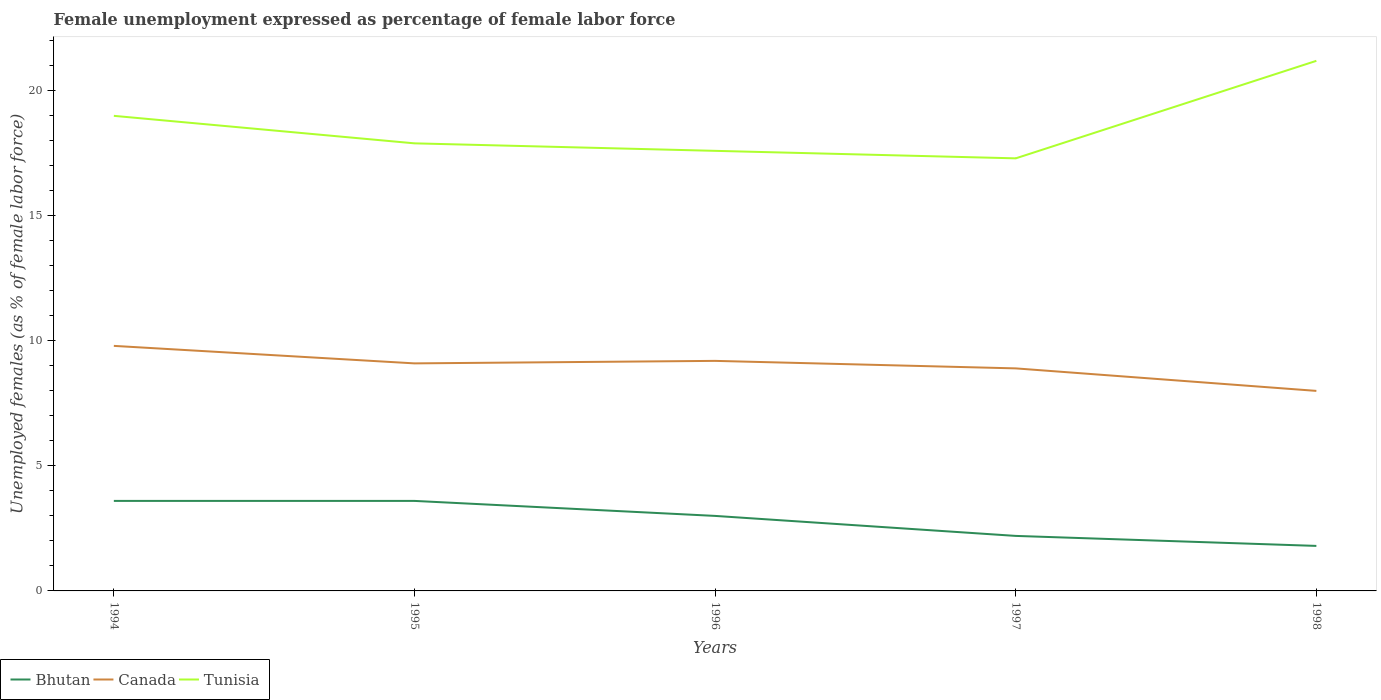How many different coloured lines are there?
Give a very brief answer. 3. Does the line corresponding to Tunisia intersect with the line corresponding to Bhutan?
Keep it short and to the point. No. Across all years, what is the maximum unemployment in females in in Bhutan?
Your response must be concise. 1.8. In which year was the unemployment in females in in Bhutan maximum?
Keep it short and to the point. 1998. What is the total unemployment in females in in Canada in the graph?
Give a very brief answer. 1.2. What is the difference between the highest and the second highest unemployment in females in in Bhutan?
Your response must be concise. 1.8. Are the values on the major ticks of Y-axis written in scientific E-notation?
Give a very brief answer. No. Does the graph contain grids?
Your answer should be very brief. No. How are the legend labels stacked?
Give a very brief answer. Horizontal. What is the title of the graph?
Give a very brief answer. Female unemployment expressed as percentage of female labor force. What is the label or title of the X-axis?
Your answer should be compact. Years. What is the label or title of the Y-axis?
Give a very brief answer. Unemployed females (as % of female labor force). What is the Unemployed females (as % of female labor force) of Bhutan in 1994?
Your answer should be compact. 3.6. What is the Unemployed females (as % of female labor force) of Canada in 1994?
Keep it short and to the point. 9.8. What is the Unemployed females (as % of female labor force) of Tunisia in 1994?
Your answer should be very brief. 19. What is the Unemployed females (as % of female labor force) in Bhutan in 1995?
Keep it short and to the point. 3.6. What is the Unemployed females (as % of female labor force) of Canada in 1995?
Offer a terse response. 9.1. What is the Unemployed females (as % of female labor force) in Tunisia in 1995?
Ensure brevity in your answer.  17.9. What is the Unemployed females (as % of female labor force) in Bhutan in 1996?
Give a very brief answer. 3. What is the Unemployed females (as % of female labor force) of Canada in 1996?
Your response must be concise. 9.2. What is the Unemployed females (as % of female labor force) of Tunisia in 1996?
Keep it short and to the point. 17.6. What is the Unemployed females (as % of female labor force) in Bhutan in 1997?
Make the answer very short. 2.2. What is the Unemployed females (as % of female labor force) of Canada in 1997?
Offer a terse response. 8.9. What is the Unemployed females (as % of female labor force) of Tunisia in 1997?
Give a very brief answer. 17.3. What is the Unemployed females (as % of female labor force) in Bhutan in 1998?
Your answer should be compact. 1.8. What is the Unemployed females (as % of female labor force) of Tunisia in 1998?
Make the answer very short. 21.2. Across all years, what is the maximum Unemployed females (as % of female labor force) in Bhutan?
Keep it short and to the point. 3.6. Across all years, what is the maximum Unemployed females (as % of female labor force) in Canada?
Make the answer very short. 9.8. Across all years, what is the maximum Unemployed females (as % of female labor force) of Tunisia?
Give a very brief answer. 21.2. Across all years, what is the minimum Unemployed females (as % of female labor force) in Bhutan?
Your answer should be compact. 1.8. Across all years, what is the minimum Unemployed females (as % of female labor force) in Tunisia?
Keep it short and to the point. 17.3. What is the total Unemployed females (as % of female labor force) of Canada in the graph?
Provide a short and direct response. 45. What is the total Unemployed females (as % of female labor force) of Tunisia in the graph?
Give a very brief answer. 93. What is the difference between the Unemployed females (as % of female labor force) in Bhutan in 1994 and that in 1995?
Provide a succinct answer. 0. What is the difference between the Unemployed females (as % of female labor force) of Canada in 1994 and that in 1995?
Keep it short and to the point. 0.7. What is the difference between the Unemployed females (as % of female labor force) in Tunisia in 1994 and that in 1995?
Give a very brief answer. 1.1. What is the difference between the Unemployed females (as % of female labor force) of Canada in 1994 and that in 1996?
Offer a very short reply. 0.6. What is the difference between the Unemployed females (as % of female labor force) of Tunisia in 1994 and that in 1996?
Ensure brevity in your answer.  1.4. What is the difference between the Unemployed females (as % of female labor force) of Bhutan in 1994 and that in 1997?
Your answer should be very brief. 1.4. What is the difference between the Unemployed females (as % of female labor force) of Bhutan in 1994 and that in 1998?
Keep it short and to the point. 1.8. What is the difference between the Unemployed females (as % of female labor force) in Canada in 1994 and that in 1998?
Provide a succinct answer. 1.8. What is the difference between the Unemployed females (as % of female labor force) in Tunisia in 1994 and that in 1998?
Offer a very short reply. -2.2. What is the difference between the Unemployed females (as % of female labor force) in Canada in 1995 and that in 1996?
Your answer should be compact. -0.1. What is the difference between the Unemployed females (as % of female labor force) of Tunisia in 1995 and that in 1996?
Ensure brevity in your answer.  0.3. What is the difference between the Unemployed females (as % of female labor force) in Bhutan in 1995 and that in 1997?
Provide a short and direct response. 1.4. What is the difference between the Unemployed females (as % of female labor force) in Tunisia in 1995 and that in 1998?
Your answer should be compact. -3.3. What is the difference between the Unemployed females (as % of female labor force) of Canada in 1996 and that in 1997?
Provide a short and direct response. 0.3. What is the difference between the Unemployed females (as % of female labor force) in Bhutan in 1996 and that in 1998?
Your answer should be compact. 1.2. What is the difference between the Unemployed females (as % of female labor force) of Canada in 1996 and that in 1998?
Provide a succinct answer. 1.2. What is the difference between the Unemployed females (as % of female labor force) of Tunisia in 1996 and that in 1998?
Make the answer very short. -3.6. What is the difference between the Unemployed females (as % of female labor force) in Bhutan in 1994 and the Unemployed females (as % of female labor force) in Tunisia in 1995?
Your response must be concise. -14.3. What is the difference between the Unemployed females (as % of female labor force) of Canada in 1994 and the Unemployed females (as % of female labor force) of Tunisia in 1995?
Make the answer very short. -8.1. What is the difference between the Unemployed females (as % of female labor force) of Bhutan in 1994 and the Unemployed females (as % of female labor force) of Canada in 1996?
Provide a succinct answer. -5.6. What is the difference between the Unemployed females (as % of female labor force) of Bhutan in 1994 and the Unemployed females (as % of female labor force) of Tunisia in 1996?
Ensure brevity in your answer.  -14. What is the difference between the Unemployed females (as % of female labor force) of Bhutan in 1994 and the Unemployed females (as % of female labor force) of Tunisia in 1997?
Offer a terse response. -13.7. What is the difference between the Unemployed females (as % of female labor force) in Canada in 1994 and the Unemployed females (as % of female labor force) in Tunisia in 1997?
Your answer should be compact. -7.5. What is the difference between the Unemployed females (as % of female labor force) in Bhutan in 1994 and the Unemployed females (as % of female labor force) in Tunisia in 1998?
Keep it short and to the point. -17.6. What is the difference between the Unemployed females (as % of female labor force) of Canada in 1994 and the Unemployed females (as % of female labor force) of Tunisia in 1998?
Keep it short and to the point. -11.4. What is the difference between the Unemployed females (as % of female labor force) in Bhutan in 1995 and the Unemployed females (as % of female labor force) in Canada in 1996?
Provide a succinct answer. -5.6. What is the difference between the Unemployed females (as % of female labor force) of Bhutan in 1995 and the Unemployed females (as % of female labor force) of Tunisia in 1997?
Your answer should be compact. -13.7. What is the difference between the Unemployed females (as % of female labor force) in Bhutan in 1995 and the Unemployed females (as % of female labor force) in Tunisia in 1998?
Make the answer very short. -17.6. What is the difference between the Unemployed females (as % of female labor force) in Canada in 1995 and the Unemployed females (as % of female labor force) in Tunisia in 1998?
Provide a short and direct response. -12.1. What is the difference between the Unemployed females (as % of female labor force) in Bhutan in 1996 and the Unemployed females (as % of female labor force) in Canada in 1997?
Provide a succinct answer. -5.9. What is the difference between the Unemployed females (as % of female labor force) in Bhutan in 1996 and the Unemployed females (as % of female labor force) in Tunisia in 1997?
Offer a terse response. -14.3. What is the difference between the Unemployed females (as % of female labor force) in Bhutan in 1996 and the Unemployed females (as % of female labor force) in Tunisia in 1998?
Offer a very short reply. -18.2. What is the difference between the Unemployed females (as % of female labor force) in Canada in 1996 and the Unemployed females (as % of female labor force) in Tunisia in 1998?
Offer a terse response. -12. What is the difference between the Unemployed females (as % of female labor force) in Bhutan in 1997 and the Unemployed females (as % of female labor force) in Canada in 1998?
Make the answer very short. -5.8. What is the difference between the Unemployed females (as % of female labor force) of Bhutan in 1997 and the Unemployed females (as % of female labor force) of Tunisia in 1998?
Keep it short and to the point. -19. What is the difference between the Unemployed females (as % of female labor force) in Canada in 1997 and the Unemployed females (as % of female labor force) in Tunisia in 1998?
Your answer should be compact. -12.3. What is the average Unemployed females (as % of female labor force) of Bhutan per year?
Make the answer very short. 2.84. What is the average Unemployed females (as % of female labor force) of Canada per year?
Offer a very short reply. 9. In the year 1994, what is the difference between the Unemployed females (as % of female labor force) in Bhutan and Unemployed females (as % of female labor force) in Tunisia?
Your answer should be very brief. -15.4. In the year 1995, what is the difference between the Unemployed females (as % of female labor force) of Bhutan and Unemployed females (as % of female labor force) of Canada?
Give a very brief answer. -5.5. In the year 1995, what is the difference between the Unemployed females (as % of female labor force) in Bhutan and Unemployed females (as % of female labor force) in Tunisia?
Offer a terse response. -14.3. In the year 1995, what is the difference between the Unemployed females (as % of female labor force) in Canada and Unemployed females (as % of female labor force) in Tunisia?
Make the answer very short. -8.8. In the year 1996, what is the difference between the Unemployed females (as % of female labor force) in Bhutan and Unemployed females (as % of female labor force) in Tunisia?
Your response must be concise. -14.6. In the year 1997, what is the difference between the Unemployed females (as % of female labor force) in Bhutan and Unemployed females (as % of female labor force) in Tunisia?
Offer a terse response. -15.1. In the year 1997, what is the difference between the Unemployed females (as % of female labor force) in Canada and Unemployed females (as % of female labor force) in Tunisia?
Offer a terse response. -8.4. In the year 1998, what is the difference between the Unemployed females (as % of female labor force) of Bhutan and Unemployed females (as % of female labor force) of Canada?
Make the answer very short. -6.2. In the year 1998, what is the difference between the Unemployed females (as % of female labor force) in Bhutan and Unemployed females (as % of female labor force) in Tunisia?
Provide a short and direct response. -19.4. In the year 1998, what is the difference between the Unemployed females (as % of female labor force) in Canada and Unemployed females (as % of female labor force) in Tunisia?
Your response must be concise. -13.2. What is the ratio of the Unemployed females (as % of female labor force) in Bhutan in 1994 to that in 1995?
Ensure brevity in your answer.  1. What is the ratio of the Unemployed females (as % of female labor force) in Canada in 1994 to that in 1995?
Your answer should be compact. 1.08. What is the ratio of the Unemployed females (as % of female labor force) in Tunisia in 1994 to that in 1995?
Provide a succinct answer. 1.06. What is the ratio of the Unemployed females (as % of female labor force) in Canada in 1994 to that in 1996?
Give a very brief answer. 1.07. What is the ratio of the Unemployed females (as % of female labor force) of Tunisia in 1994 to that in 1996?
Provide a short and direct response. 1.08. What is the ratio of the Unemployed females (as % of female labor force) of Bhutan in 1994 to that in 1997?
Your answer should be compact. 1.64. What is the ratio of the Unemployed females (as % of female labor force) in Canada in 1994 to that in 1997?
Ensure brevity in your answer.  1.1. What is the ratio of the Unemployed females (as % of female labor force) of Tunisia in 1994 to that in 1997?
Offer a terse response. 1.1. What is the ratio of the Unemployed females (as % of female labor force) in Canada in 1994 to that in 1998?
Ensure brevity in your answer.  1.23. What is the ratio of the Unemployed females (as % of female labor force) in Tunisia in 1994 to that in 1998?
Your answer should be compact. 0.9. What is the ratio of the Unemployed females (as % of female labor force) in Bhutan in 1995 to that in 1996?
Offer a very short reply. 1.2. What is the ratio of the Unemployed females (as % of female labor force) in Tunisia in 1995 to that in 1996?
Make the answer very short. 1.02. What is the ratio of the Unemployed females (as % of female labor force) in Bhutan in 1995 to that in 1997?
Keep it short and to the point. 1.64. What is the ratio of the Unemployed females (as % of female labor force) in Canada in 1995 to that in 1997?
Ensure brevity in your answer.  1.02. What is the ratio of the Unemployed females (as % of female labor force) in Tunisia in 1995 to that in 1997?
Offer a terse response. 1.03. What is the ratio of the Unemployed females (as % of female labor force) of Canada in 1995 to that in 1998?
Ensure brevity in your answer.  1.14. What is the ratio of the Unemployed females (as % of female labor force) of Tunisia in 1995 to that in 1998?
Offer a terse response. 0.84. What is the ratio of the Unemployed females (as % of female labor force) of Bhutan in 1996 to that in 1997?
Your answer should be compact. 1.36. What is the ratio of the Unemployed females (as % of female labor force) in Canada in 1996 to that in 1997?
Ensure brevity in your answer.  1.03. What is the ratio of the Unemployed females (as % of female labor force) in Tunisia in 1996 to that in 1997?
Offer a very short reply. 1.02. What is the ratio of the Unemployed females (as % of female labor force) in Canada in 1996 to that in 1998?
Offer a terse response. 1.15. What is the ratio of the Unemployed females (as % of female labor force) of Tunisia in 1996 to that in 1998?
Your answer should be very brief. 0.83. What is the ratio of the Unemployed females (as % of female labor force) of Bhutan in 1997 to that in 1998?
Give a very brief answer. 1.22. What is the ratio of the Unemployed females (as % of female labor force) of Canada in 1997 to that in 1998?
Provide a short and direct response. 1.11. What is the ratio of the Unemployed females (as % of female labor force) in Tunisia in 1997 to that in 1998?
Provide a short and direct response. 0.82. What is the difference between the highest and the second highest Unemployed females (as % of female labor force) of Bhutan?
Provide a succinct answer. 0. What is the difference between the highest and the lowest Unemployed females (as % of female labor force) of Bhutan?
Provide a succinct answer. 1.8. What is the difference between the highest and the lowest Unemployed females (as % of female labor force) of Canada?
Offer a terse response. 1.8. What is the difference between the highest and the lowest Unemployed females (as % of female labor force) in Tunisia?
Your answer should be very brief. 3.9. 